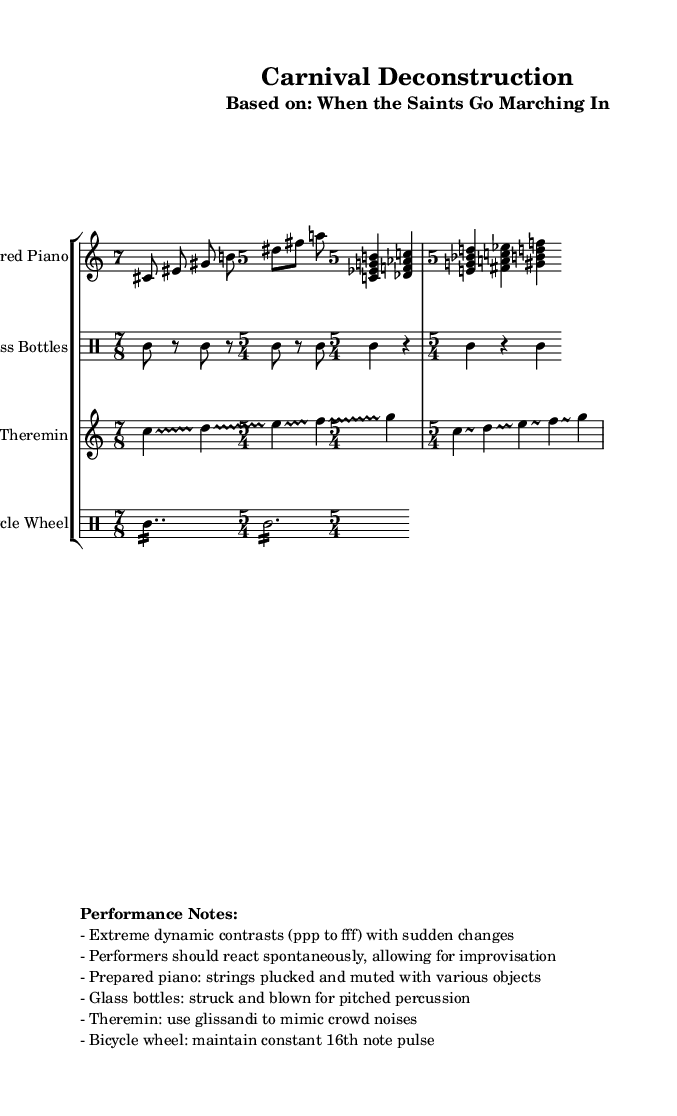What is the tempo range indicated in the sheet music? The tempo is marked as "4 = 60-120," indicating that the beats per minute can vary between 60 and 120.
Answer: 60-120 What is the time signature of the Prepared Piano section? The Prepared Piano section starts with a time signature of 7/8, followed by 5/4, showing a shift in meter as the music progresses.
Answer: 7/8, 5/4 Which instruments are used in this composition? The sheet music lists four different instruments: Prepared Piano, Glass Bottles, Theremin, and Bicycle Wheel, as indicated at the beginning of each staff.
Answer: Prepared Piano, Glass Bottles, Theremin, Bicycle Wheel What unique performance note is specified for the Theremin? The performance note for the Theremin specifies using glissandi to mimic crowd noises, highlighting the unconventional approach to its sound in this piece.
Answer: Glissandi How many measures are in the Bicycle Wheel section? In the Bicycle Wheel section, there are a total of two measures: the first measure is in 7/8, and the second measure is in 5/4, indicating the different rhythmic structures.
Answer: 2 What is suggested for dynamic changes in the performance? The performance notes suggest extreme dynamic contrasts from pp to fff with sudden changes, indicating a significant range of loudness for the performers.
Answer: Extreme dynamics 